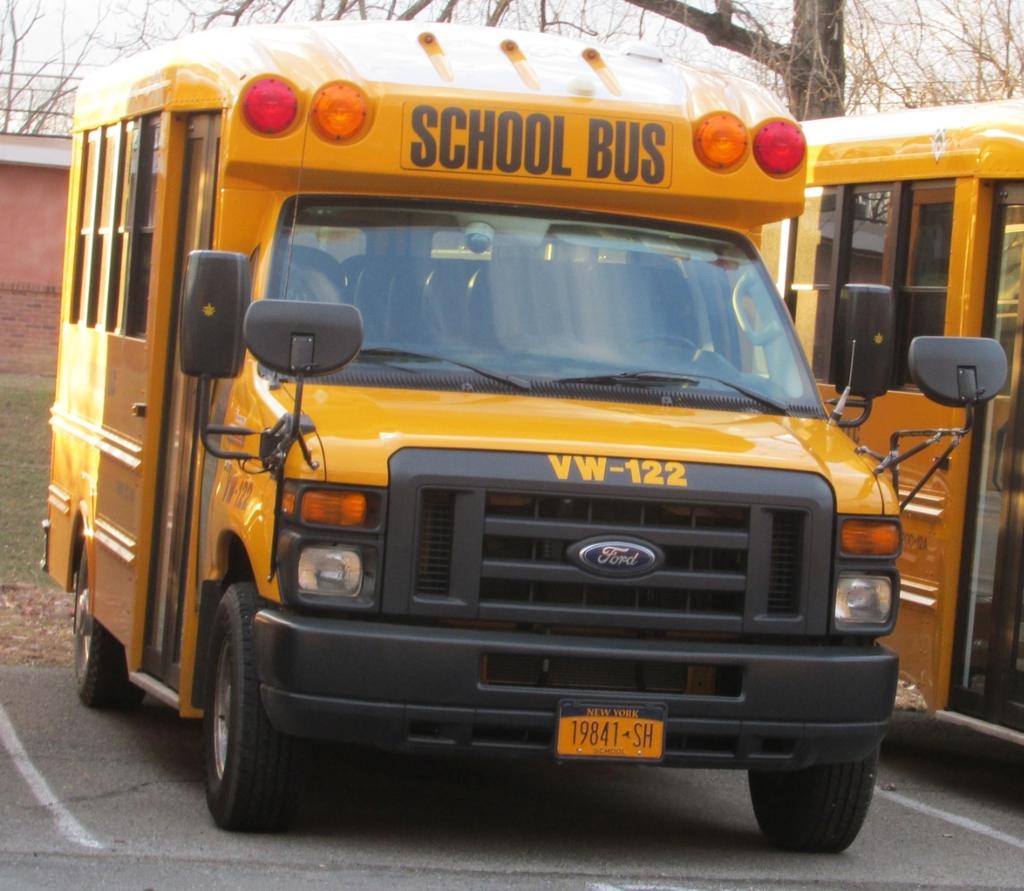What state is this school bus in?
Offer a terse response. New york. What is the auto brand on the front of the bus?
Your answer should be very brief. Ford. 